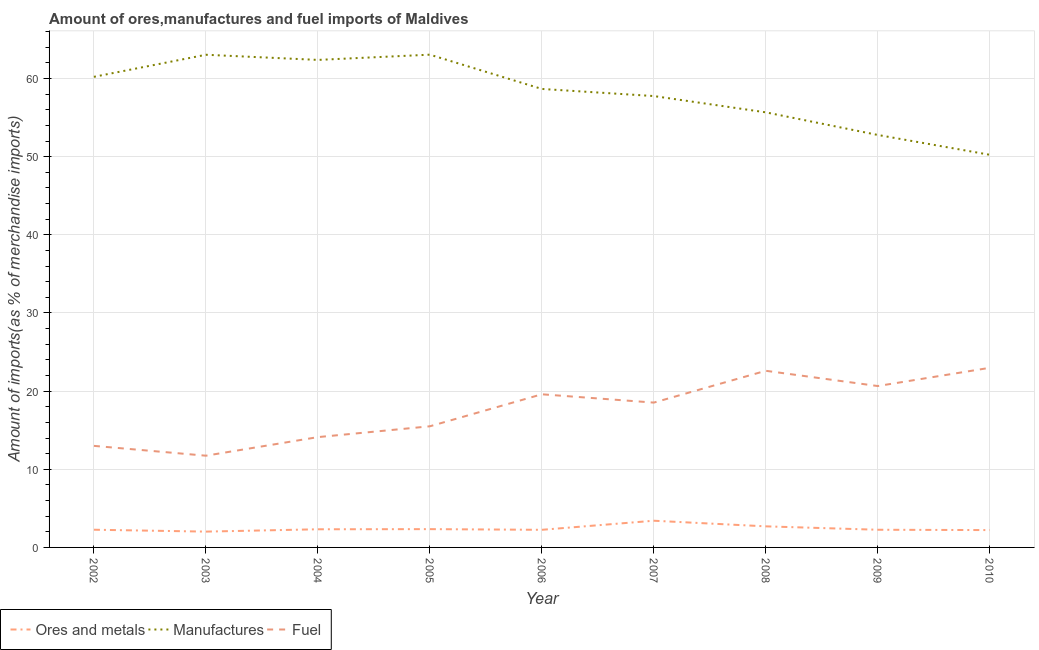Does the line corresponding to percentage of ores and metals imports intersect with the line corresponding to percentage of fuel imports?
Make the answer very short. No. Is the number of lines equal to the number of legend labels?
Offer a terse response. Yes. What is the percentage of fuel imports in 2008?
Offer a terse response. 22.6. Across all years, what is the maximum percentage of manufactures imports?
Make the answer very short. 63.05. Across all years, what is the minimum percentage of fuel imports?
Provide a succinct answer. 11.74. In which year was the percentage of manufactures imports maximum?
Provide a short and direct response. 2005. In which year was the percentage of fuel imports minimum?
Your answer should be very brief. 2003. What is the total percentage of manufactures imports in the graph?
Your response must be concise. 523.8. What is the difference between the percentage of manufactures imports in 2002 and that in 2006?
Offer a very short reply. 1.55. What is the difference between the percentage of fuel imports in 2010 and the percentage of ores and metals imports in 2005?
Make the answer very short. 20.64. What is the average percentage of fuel imports per year?
Offer a terse response. 17.63. In the year 2008, what is the difference between the percentage of fuel imports and percentage of manufactures imports?
Your response must be concise. -33.07. In how many years, is the percentage of fuel imports greater than 36 %?
Offer a terse response. 0. What is the ratio of the percentage of manufactures imports in 2005 to that in 2010?
Ensure brevity in your answer.  1.25. Is the difference between the percentage of ores and metals imports in 2002 and 2010 greater than the difference between the percentage of manufactures imports in 2002 and 2010?
Your response must be concise. No. What is the difference between the highest and the second highest percentage of manufactures imports?
Ensure brevity in your answer.  0.01. What is the difference between the highest and the lowest percentage of fuel imports?
Keep it short and to the point. 11.25. Is the sum of the percentage of ores and metals imports in 2006 and 2009 greater than the maximum percentage of fuel imports across all years?
Keep it short and to the point. No. Is it the case that in every year, the sum of the percentage of ores and metals imports and percentage of manufactures imports is greater than the percentage of fuel imports?
Your response must be concise. Yes. Does the percentage of fuel imports monotonically increase over the years?
Your answer should be compact. No. Is the percentage of manufactures imports strictly greater than the percentage of ores and metals imports over the years?
Provide a short and direct response. Yes. Are the values on the major ticks of Y-axis written in scientific E-notation?
Provide a short and direct response. No. How many legend labels are there?
Ensure brevity in your answer.  3. What is the title of the graph?
Provide a short and direct response. Amount of ores,manufactures and fuel imports of Maldives. What is the label or title of the Y-axis?
Offer a terse response. Amount of imports(as % of merchandise imports). What is the Amount of imports(as % of merchandise imports) of Ores and metals in 2002?
Your answer should be very brief. 2.26. What is the Amount of imports(as % of merchandise imports) of Manufactures in 2002?
Give a very brief answer. 60.22. What is the Amount of imports(as % of merchandise imports) in Fuel in 2002?
Ensure brevity in your answer.  13. What is the Amount of imports(as % of merchandise imports) in Ores and metals in 2003?
Keep it short and to the point. 2.02. What is the Amount of imports(as % of merchandise imports) of Manufactures in 2003?
Ensure brevity in your answer.  63.04. What is the Amount of imports(as % of merchandise imports) in Fuel in 2003?
Offer a terse response. 11.74. What is the Amount of imports(as % of merchandise imports) in Ores and metals in 2004?
Make the answer very short. 2.32. What is the Amount of imports(as % of merchandise imports) in Manufactures in 2004?
Offer a terse response. 62.38. What is the Amount of imports(as % of merchandise imports) in Fuel in 2004?
Give a very brief answer. 14.11. What is the Amount of imports(as % of merchandise imports) in Ores and metals in 2005?
Give a very brief answer. 2.34. What is the Amount of imports(as % of merchandise imports) in Manufactures in 2005?
Your response must be concise. 63.05. What is the Amount of imports(as % of merchandise imports) in Fuel in 2005?
Ensure brevity in your answer.  15.5. What is the Amount of imports(as % of merchandise imports) of Ores and metals in 2006?
Your answer should be very brief. 2.25. What is the Amount of imports(as % of merchandise imports) of Manufactures in 2006?
Offer a terse response. 58.67. What is the Amount of imports(as % of merchandise imports) in Fuel in 2006?
Your response must be concise. 19.6. What is the Amount of imports(as % of merchandise imports) in Ores and metals in 2007?
Your answer should be compact. 3.42. What is the Amount of imports(as % of merchandise imports) in Manufactures in 2007?
Offer a very short reply. 57.75. What is the Amount of imports(as % of merchandise imports) in Fuel in 2007?
Provide a succinct answer. 18.53. What is the Amount of imports(as % of merchandise imports) in Ores and metals in 2008?
Offer a terse response. 2.7. What is the Amount of imports(as % of merchandise imports) of Manufactures in 2008?
Offer a terse response. 55.67. What is the Amount of imports(as % of merchandise imports) of Fuel in 2008?
Give a very brief answer. 22.6. What is the Amount of imports(as % of merchandise imports) in Ores and metals in 2009?
Your response must be concise. 2.26. What is the Amount of imports(as % of merchandise imports) in Manufactures in 2009?
Offer a very short reply. 52.78. What is the Amount of imports(as % of merchandise imports) of Fuel in 2009?
Provide a short and direct response. 20.65. What is the Amount of imports(as % of merchandise imports) in Ores and metals in 2010?
Your answer should be compact. 2.22. What is the Amount of imports(as % of merchandise imports) of Manufactures in 2010?
Your response must be concise. 50.24. What is the Amount of imports(as % of merchandise imports) of Fuel in 2010?
Your answer should be very brief. 22.98. Across all years, what is the maximum Amount of imports(as % of merchandise imports) in Ores and metals?
Keep it short and to the point. 3.42. Across all years, what is the maximum Amount of imports(as % of merchandise imports) of Manufactures?
Offer a terse response. 63.05. Across all years, what is the maximum Amount of imports(as % of merchandise imports) in Fuel?
Ensure brevity in your answer.  22.98. Across all years, what is the minimum Amount of imports(as % of merchandise imports) of Ores and metals?
Provide a succinct answer. 2.02. Across all years, what is the minimum Amount of imports(as % of merchandise imports) of Manufactures?
Your answer should be compact. 50.24. Across all years, what is the minimum Amount of imports(as % of merchandise imports) in Fuel?
Give a very brief answer. 11.74. What is the total Amount of imports(as % of merchandise imports) of Ores and metals in the graph?
Make the answer very short. 21.8. What is the total Amount of imports(as % of merchandise imports) in Manufactures in the graph?
Offer a very short reply. 523.8. What is the total Amount of imports(as % of merchandise imports) of Fuel in the graph?
Provide a succinct answer. 158.71. What is the difference between the Amount of imports(as % of merchandise imports) of Ores and metals in 2002 and that in 2003?
Make the answer very short. 0.24. What is the difference between the Amount of imports(as % of merchandise imports) of Manufactures in 2002 and that in 2003?
Make the answer very short. -2.82. What is the difference between the Amount of imports(as % of merchandise imports) of Fuel in 2002 and that in 2003?
Give a very brief answer. 1.26. What is the difference between the Amount of imports(as % of merchandise imports) of Ores and metals in 2002 and that in 2004?
Your response must be concise. -0.06. What is the difference between the Amount of imports(as % of merchandise imports) of Manufactures in 2002 and that in 2004?
Offer a terse response. -2.16. What is the difference between the Amount of imports(as % of merchandise imports) in Fuel in 2002 and that in 2004?
Offer a very short reply. -1.12. What is the difference between the Amount of imports(as % of merchandise imports) of Ores and metals in 2002 and that in 2005?
Your answer should be compact. -0.08. What is the difference between the Amount of imports(as % of merchandise imports) in Manufactures in 2002 and that in 2005?
Your answer should be compact. -2.83. What is the difference between the Amount of imports(as % of merchandise imports) in Fuel in 2002 and that in 2005?
Your answer should be compact. -2.5. What is the difference between the Amount of imports(as % of merchandise imports) in Ores and metals in 2002 and that in 2006?
Offer a very short reply. 0.01. What is the difference between the Amount of imports(as % of merchandise imports) of Manufactures in 2002 and that in 2006?
Ensure brevity in your answer.  1.55. What is the difference between the Amount of imports(as % of merchandise imports) in Fuel in 2002 and that in 2006?
Offer a terse response. -6.6. What is the difference between the Amount of imports(as % of merchandise imports) in Ores and metals in 2002 and that in 2007?
Ensure brevity in your answer.  -1.15. What is the difference between the Amount of imports(as % of merchandise imports) in Manufactures in 2002 and that in 2007?
Give a very brief answer. 2.46. What is the difference between the Amount of imports(as % of merchandise imports) in Fuel in 2002 and that in 2007?
Give a very brief answer. -5.54. What is the difference between the Amount of imports(as % of merchandise imports) of Ores and metals in 2002 and that in 2008?
Make the answer very short. -0.43. What is the difference between the Amount of imports(as % of merchandise imports) of Manufactures in 2002 and that in 2008?
Offer a very short reply. 4.54. What is the difference between the Amount of imports(as % of merchandise imports) of Fuel in 2002 and that in 2008?
Your response must be concise. -9.61. What is the difference between the Amount of imports(as % of merchandise imports) of Ores and metals in 2002 and that in 2009?
Provide a short and direct response. 0. What is the difference between the Amount of imports(as % of merchandise imports) of Manufactures in 2002 and that in 2009?
Give a very brief answer. 7.44. What is the difference between the Amount of imports(as % of merchandise imports) of Fuel in 2002 and that in 2009?
Give a very brief answer. -7.66. What is the difference between the Amount of imports(as % of merchandise imports) of Ores and metals in 2002 and that in 2010?
Give a very brief answer. 0.05. What is the difference between the Amount of imports(as % of merchandise imports) in Manufactures in 2002 and that in 2010?
Keep it short and to the point. 9.97. What is the difference between the Amount of imports(as % of merchandise imports) of Fuel in 2002 and that in 2010?
Offer a terse response. -9.99. What is the difference between the Amount of imports(as % of merchandise imports) in Ores and metals in 2003 and that in 2004?
Offer a very short reply. -0.3. What is the difference between the Amount of imports(as % of merchandise imports) of Manufactures in 2003 and that in 2004?
Your answer should be compact. 0.66. What is the difference between the Amount of imports(as % of merchandise imports) in Fuel in 2003 and that in 2004?
Offer a terse response. -2.38. What is the difference between the Amount of imports(as % of merchandise imports) in Ores and metals in 2003 and that in 2005?
Provide a succinct answer. -0.32. What is the difference between the Amount of imports(as % of merchandise imports) of Manufactures in 2003 and that in 2005?
Your response must be concise. -0.01. What is the difference between the Amount of imports(as % of merchandise imports) in Fuel in 2003 and that in 2005?
Give a very brief answer. -3.76. What is the difference between the Amount of imports(as % of merchandise imports) in Ores and metals in 2003 and that in 2006?
Provide a short and direct response. -0.23. What is the difference between the Amount of imports(as % of merchandise imports) of Manufactures in 2003 and that in 2006?
Your response must be concise. 4.37. What is the difference between the Amount of imports(as % of merchandise imports) in Fuel in 2003 and that in 2006?
Your answer should be compact. -7.86. What is the difference between the Amount of imports(as % of merchandise imports) in Ores and metals in 2003 and that in 2007?
Your response must be concise. -1.39. What is the difference between the Amount of imports(as % of merchandise imports) of Manufactures in 2003 and that in 2007?
Give a very brief answer. 5.28. What is the difference between the Amount of imports(as % of merchandise imports) of Fuel in 2003 and that in 2007?
Provide a short and direct response. -6.79. What is the difference between the Amount of imports(as % of merchandise imports) in Ores and metals in 2003 and that in 2008?
Your answer should be compact. -0.67. What is the difference between the Amount of imports(as % of merchandise imports) of Manufactures in 2003 and that in 2008?
Provide a short and direct response. 7.37. What is the difference between the Amount of imports(as % of merchandise imports) of Fuel in 2003 and that in 2008?
Your answer should be very brief. -10.87. What is the difference between the Amount of imports(as % of merchandise imports) of Ores and metals in 2003 and that in 2009?
Provide a short and direct response. -0.24. What is the difference between the Amount of imports(as % of merchandise imports) in Manufactures in 2003 and that in 2009?
Provide a succinct answer. 10.26. What is the difference between the Amount of imports(as % of merchandise imports) of Fuel in 2003 and that in 2009?
Offer a very short reply. -8.91. What is the difference between the Amount of imports(as % of merchandise imports) in Ores and metals in 2003 and that in 2010?
Your response must be concise. -0.2. What is the difference between the Amount of imports(as % of merchandise imports) in Manufactures in 2003 and that in 2010?
Give a very brief answer. 12.8. What is the difference between the Amount of imports(as % of merchandise imports) in Fuel in 2003 and that in 2010?
Offer a terse response. -11.25. What is the difference between the Amount of imports(as % of merchandise imports) in Ores and metals in 2004 and that in 2005?
Offer a very short reply. -0.02. What is the difference between the Amount of imports(as % of merchandise imports) in Manufactures in 2004 and that in 2005?
Give a very brief answer. -0.67. What is the difference between the Amount of imports(as % of merchandise imports) of Fuel in 2004 and that in 2005?
Your response must be concise. -1.39. What is the difference between the Amount of imports(as % of merchandise imports) of Ores and metals in 2004 and that in 2006?
Your response must be concise. 0.07. What is the difference between the Amount of imports(as % of merchandise imports) in Manufactures in 2004 and that in 2006?
Provide a succinct answer. 3.71. What is the difference between the Amount of imports(as % of merchandise imports) of Fuel in 2004 and that in 2006?
Provide a succinct answer. -5.48. What is the difference between the Amount of imports(as % of merchandise imports) in Ores and metals in 2004 and that in 2007?
Your answer should be compact. -1.09. What is the difference between the Amount of imports(as % of merchandise imports) of Manufactures in 2004 and that in 2007?
Provide a succinct answer. 4.63. What is the difference between the Amount of imports(as % of merchandise imports) in Fuel in 2004 and that in 2007?
Keep it short and to the point. -4.42. What is the difference between the Amount of imports(as % of merchandise imports) of Ores and metals in 2004 and that in 2008?
Offer a terse response. -0.37. What is the difference between the Amount of imports(as % of merchandise imports) of Manufactures in 2004 and that in 2008?
Your answer should be compact. 6.71. What is the difference between the Amount of imports(as % of merchandise imports) in Fuel in 2004 and that in 2008?
Provide a short and direct response. -8.49. What is the difference between the Amount of imports(as % of merchandise imports) in Ores and metals in 2004 and that in 2009?
Offer a very short reply. 0.06. What is the difference between the Amount of imports(as % of merchandise imports) of Manufactures in 2004 and that in 2009?
Provide a succinct answer. 9.6. What is the difference between the Amount of imports(as % of merchandise imports) of Fuel in 2004 and that in 2009?
Your answer should be very brief. -6.54. What is the difference between the Amount of imports(as % of merchandise imports) in Ores and metals in 2004 and that in 2010?
Your answer should be compact. 0.1. What is the difference between the Amount of imports(as % of merchandise imports) in Manufactures in 2004 and that in 2010?
Your response must be concise. 12.14. What is the difference between the Amount of imports(as % of merchandise imports) in Fuel in 2004 and that in 2010?
Your answer should be compact. -8.87. What is the difference between the Amount of imports(as % of merchandise imports) in Ores and metals in 2005 and that in 2006?
Offer a very short reply. 0.09. What is the difference between the Amount of imports(as % of merchandise imports) of Manufactures in 2005 and that in 2006?
Ensure brevity in your answer.  4.38. What is the difference between the Amount of imports(as % of merchandise imports) in Fuel in 2005 and that in 2006?
Make the answer very short. -4.1. What is the difference between the Amount of imports(as % of merchandise imports) in Ores and metals in 2005 and that in 2007?
Give a very brief answer. -1.07. What is the difference between the Amount of imports(as % of merchandise imports) of Manufactures in 2005 and that in 2007?
Ensure brevity in your answer.  5.3. What is the difference between the Amount of imports(as % of merchandise imports) in Fuel in 2005 and that in 2007?
Keep it short and to the point. -3.03. What is the difference between the Amount of imports(as % of merchandise imports) in Ores and metals in 2005 and that in 2008?
Your answer should be very brief. -0.36. What is the difference between the Amount of imports(as % of merchandise imports) in Manufactures in 2005 and that in 2008?
Keep it short and to the point. 7.38. What is the difference between the Amount of imports(as % of merchandise imports) in Fuel in 2005 and that in 2008?
Keep it short and to the point. -7.1. What is the difference between the Amount of imports(as % of merchandise imports) of Ores and metals in 2005 and that in 2009?
Give a very brief answer. 0.08. What is the difference between the Amount of imports(as % of merchandise imports) in Manufactures in 2005 and that in 2009?
Your answer should be compact. 10.27. What is the difference between the Amount of imports(as % of merchandise imports) of Fuel in 2005 and that in 2009?
Your answer should be very brief. -5.15. What is the difference between the Amount of imports(as % of merchandise imports) of Ores and metals in 2005 and that in 2010?
Give a very brief answer. 0.12. What is the difference between the Amount of imports(as % of merchandise imports) in Manufactures in 2005 and that in 2010?
Your answer should be compact. 12.81. What is the difference between the Amount of imports(as % of merchandise imports) of Fuel in 2005 and that in 2010?
Provide a short and direct response. -7.48. What is the difference between the Amount of imports(as % of merchandise imports) of Ores and metals in 2006 and that in 2007?
Make the answer very short. -1.16. What is the difference between the Amount of imports(as % of merchandise imports) of Manufactures in 2006 and that in 2007?
Provide a short and direct response. 0.91. What is the difference between the Amount of imports(as % of merchandise imports) in Fuel in 2006 and that in 2007?
Make the answer very short. 1.06. What is the difference between the Amount of imports(as % of merchandise imports) in Ores and metals in 2006 and that in 2008?
Give a very brief answer. -0.44. What is the difference between the Amount of imports(as % of merchandise imports) of Manufactures in 2006 and that in 2008?
Provide a succinct answer. 2.99. What is the difference between the Amount of imports(as % of merchandise imports) of Fuel in 2006 and that in 2008?
Your response must be concise. -3.01. What is the difference between the Amount of imports(as % of merchandise imports) in Ores and metals in 2006 and that in 2009?
Offer a very short reply. -0.01. What is the difference between the Amount of imports(as % of merchandise imports) in Manufactures in 2006 and that in 2009?
Give a very brief answer. 5.89. What is the difference between the Amount of imports(as % of merchandise imports) of Fuel in 2006 and that in 2009?
Provide a succinct answer. -1.06. What is the difference between the Amount of imports(as % of merchandise imports) in Ores and metals in 2006 and that in 2010?
Offer a terse response. 0.04. What is the difference between the Amount of imports(as % of merchandise imports) of Manufactures in 2006 and that in 2010?
Offer a very short reply. 8.42. What is the difference between the Amount of imports(as % of merchandise imports) of Fuel in 2006 and that in 2010?
Give a very brief answer. -3.39. What is the difference between the Amount of imports(as % of merchandise imports) of Ores and metals in 2007 and that in 2008?
Ensure brevity in your answer.  0.72. What is the difference between the Amount of imports(as % of merchandise imports) of Manufactures in 2007 and that in 2008?
Ensure brevity in your answer.  2.08. What is the difference between the Amount of imports(as % of merchandise imports) in Fuel in 2007 and that in 2008?
Your answer should be very brief. -4.07. What is the difference between the Amount of imports(as % of merchandise imports) of Ores and metals in 2007 and that in 2009?
Your answer should be very brief. 1.15. What is the difference between the Amount of imports(as % of merchandise imports) in Manufactures in 2007 and that in 2009?
Provide a short and direct response. 4.98. What is the difference between the Amount of imports(as % of merchandise imports) of Fuel in 2007 and that in 2009?
Your response must be concise. -2.12. What is the difference between the Amount of imports(as % of merchandise imports) in Ores and metals in 2007 and that in 2010?
Keep it short and to the point. 1.2. What is the difference between the Amount of imports(as % of merchandise imports) in Manufactures in 2007 and that in 2010?
Make the answer very short. 7.51. What is the difference between the Amount of imports(as % of merchandise imports) in Fuel in 2007 and that in 2010?
Offer a very short reply. -4.45. What is the difference between the Amount of imports(as % of merchandise imports) in Ores and metals in 2008 and that in 2009?
Your answer should be compact. 0.43. What is the difference between the Amount of imports(as % of merchandise imports) of Manufactures in 2008 and that in 2009?
Your answer should be compact. 2.89. What is the difference between the Amount of imports(as % of merchandise imports) in Fuel in 2008 and that in 2009?
Provide a short and direct response. 1.95. What is the difference between the Amount of imports(as % of merchandise imports) in Ores and metals in 2008 and that in 2010?
Your response must be concise. 0.48. What is the difference between the Amount of imports(as % of merchandise imports) in Manufactures in 2008 and that in 2010?
Give a very brief answer. 5.43. What is the difference between the Amount of imports(as % of merchandise imports) of Fuel in 2008 and that in 2010?
Your answer should be compact. -0.38. What is the difference between the Amount of imports(as % of merchandise imports) in Ores and metals in 2009 and that in 2010?
Your answer should be compact. 0.04. What is the difference between the Amount of imports(as % of merchandise imports) of Manufactures in 2009 and that in 2010?
Your answer should be very brief. 2.54. What is the difference between the Amount of imports(as % of merchandise imports) in Fuel in 2009 and that in 2010?
Your answer should be very brief. -2.33. What is the difference between the Amount of imports(as % of merchandise imports) of Ores and metals in 2002 and the Amount of imports(as % of merchandise imports) of Manufactures in 2003?
Ensure brevity in your answer.  -60.77. What is the difference between the Amount of imports(as % of merchandise imports) in Ores and metals in 2002 and the Amount of imports(as % of merchandise imports) in Fuel in 2003?
Keep it short and to the point. -9.47. What is the difference between the Amount of imports(as % of merchandise imports) in Manufactures in 2002 and the Amount of imports(as % of merchandise imports) in Fuel in 2003?
Make the answer very short. 48.48. What is the difference between the Amount of imports(as % of merchandise imports) in Ores and metals in 2002 and the Amount of imports(as % of merchandise imports) in Manufactures in 2004?
Keep it short and to the point. -60.12. What is the difference between the Amount of imports(as % of merchandise imports) in Ores and metals in 2002 and the Amount of imports(as % of merchandise imports) in Fuel in 2004?
Keep it short and to the point. -11.85. What is the difference between the Amount of imports(as % of merchandise imports) in Manufactures in 2002 and the Amount of imports(as % of merchandise imports) in Fuel in 2004?
Keep it short and to the point. 46.1. What is the difference between the Amount of imports(as % of merchandise imports) of Ores and metals in 2002 and the Amount of imports(as % of merchandise imports) of Manufactures in 2005?
Provide a short and direct response. -60.79. What is the difference between the Amount of imports(as % of merchandise imports) of Ores and metals in 2002 and the Amount of imports(as % of merchandise imports) of Fuel in 2005?
Make the answer very short. -13.24. What is the difference between the Amount of imports(as % of merchandise imports) of Manufactures in 2002 and the Amount of imports(as % of merchandise imports) of Fuel in 2005?
Your answer should be compact. 44.72. What is the difference between the Amount of imports(as % of merchandise imports) of Ores and metals in 2002 and the Amount of imports(as % of merchandise imports) of Manufactures in 2006?
Offer a very short reply. -56.4. What is the difference between the Amount of imports(as % of merchandise imports) of Ores and metals in 2002 and the Amount of imports(as % of merchandise imports) of Fuel in 2006?
Your response must be concise. -17.33. What is the difference between the Amount of imports(as % of merchandise imports) in Manufactures in 2002 and the Amount of imports(as % of merchandise imports) in Fuel in 2006?
Offer a very short reply. 40.62. What is the difference between the Amount of imports(as % of merchandise imports) in Ores and metals in 2002 and the Amount of imports(as % of merchandise imports) in Manufactures in 2007?
Keep it short and to the point. -55.49. What is the difference between the Amount of imports(as % of merchandise imports) in Ores and metals in 2002 and the Amount of imports(as % of merchandise imports) in Fuel in 2007?
Your response must be concise. -16.27. What is the difference between the Amount of imports(as % of merchandise imports) in Manufactures in 2002 and the Amount of imports(as % of merchandise imports) in Fuel in 2007?
Provide a short and direct response. 41.68. What is the difference between the Amount of imports(as % of merchandise imports) in Ores and metals in 2002 and the Amount of imports(as % of merchandise imports) in Manufactures in 2008?
Your answer should be very brief. -53.41. What is the difference between the Amount of imports(as % of merchandise imports) of Ores and metals in 2002 and the Amount of imports(as % of merchandise imports) of Fuel in 2008?
Your answer should be compact. -20.34. What is the difference between the Amount of imports(as % of merchandise imports) in Manufactures in 2002 and the Amount of imports(as % of merchandise imports) in Fuel in 2008?
Your response must be concise. 37.61. What is the difference between the Amount of imports(as % of merchandise imports) of Ores and metals in 2002 and the Amount of imports(as % of merchandise imports) of Manufactures in 2009?
Your answer should be compact. -50.51. What is the difference between the Amount of imports(as % of merchandise imports) of Ores and metals in 2002 and the Amount of imports(as % of merchandise imports) of Fuel in 2009?
Your answer should be very brief. -18.39. What is the difference between the Amount of imports(as % of merchandise imports) of Manufactures in 2002 and the Amount of imports(as % of merchandise imports) of Fuel in 2009?
Offer a terse response. 39.57. What is the difference between the Amount of imports(as % of merchandise imports) of Ores and metals in 2002 and the Amount of imports(as % of merchandise imports) of Manufactures in 2010?
Offer a very short reply. -47.98. What is the difference between the Amount of imports(as % of merchandise imports) in Ores and metals in 2002 and the Amount of imports(as % of merchandise imports) in Fuel in 2010?
Your answer should be compact. -20.72. What is the difference between the Amount of imports(as % of merchandise imports) of Manufactures in 2002 and the Amount of imports(as % of merchandise imports) of Fuel in 2010?
Offer a very short reply. 37.23. What is the difference between the Amount of imports(as % of merchandise imports) of Ores and metals in 2003 and the Amount of imports(as % of merchandise imports) of Manufactures in 2004?
Your answer should be compact. -60.36. What is the difference between the Amount of imports(as % of merchandise imports) of Ores and metals in 2003 and the Amount of imports(as % of merchandise imports) of Fuel in 2004?
Keep it short and to the point. -12.09. What is the difference between the Amount of imports(as % of merchandise imports) in Manufactures in 2003 and the Amount of imports(as % of merchandise imports) in Fuel in 2004?
Offer a very short reply. 48.93. What is the difference between the Amount of imports(as % of merchandise imports) of Ores and metals in 2003 and the Amount of imports(as % of merchandise imports) of Manufactures in 2005?
Offer a terse response. -61.03. What is the difference between the Amount of imports(as % of merchandise imports) of Ores and metals in 2003 and the Amount of imports(as % of merchandise imports) of Fuel in 2005?
Provide a succinct answer. -13.48. What is the difference between the Amount of imports(as % of merchandise imports) in Manufactures in 2003 and the Amount of imports(as % of merchandise imports) in Fuel in 2005?
Ensure brevity in your answer.  47.54. What is the difference between the Amount of imports(as % of merchandise imports) in Ores and metals in 2003 and the Amount of imports(as % of merchandise imports) in Manufactures in 2006?
Give a very brief answer. -56.64. What is the difference between the Amount of imports(as % of merchandise imports) in Ores and metals in 2003 and the Amount of imports(as % of merchandise imports) in Fuel in 2006?
Your answer should be compact. -17.57. What is the difference between the Amount of imports(as % of merchandise imports) in Manufactures in 2003 and the Amount of imports(as % of merchandise imports) in Fuel in 2006?
Give a very brief answer. 43.44. What is the difference between the Amount of imports(as % of merchandise imports) of Ores and metals in 2003 and the Amount of imports(as % of merchandise imports) of Manufactures in 2007?
Provide a short and direct response. -55.73. What is the difference between the Amount of imports(as % of merchandise imports) of Ores and metals in 2003 and the Amount of imports(as % of merchandise imports) of Fuel in 2007?
Your answer should be compact. -16.51. What is the difference between the Amount of imports(as % of merchandise imports) of Manufactures in 2003 and the Amount of imports(as % of merchandise imports) of Fuel in 2007?
Your answer should be compact. 44.51. What is the difference between the Amount of imports(as % of merchandise imports) of Ores and metals in 2003 and the Amount of imports(as % of merchandise imports) of Manufactures in 2008?
Your answer should be compact. -53.65. What is the difference between the Amount of imports(as % of merchandise imports) of Ores and metals in 2003 and the Amount of imports(as % of merchandise imports) of Fuel in 2008?
Make the answer very short. -20.58. What is the difference between the Amount of imports(as % of merchandise imports) of Manufactures in 2003 and the Amount of imports(as % of merchandise imports) of Fuel in 2008?
Offer a very short reply. 40.44. What is the difference between the Amount of imports(as % of merchandise imports) in Ores and metals in 2003 and the Amount of imports(as % of merchandise imports) in Manufactures in 2009?
Ensure brevity in your answer.  -50.76. What is the difference between the Amount of imports(as % of merchandise imports) in Ores and metals in 2003 and the Amount of imports(as % of merchandise imports) in Fuel in 2009?
Your answer should be compact. -18.63. What is the difference between the Amount of imports(as % of merchandise imports) in Manufactures in 2003 and the Amount of imports(as % of merchandise imports) in Fuel in 2009?
Ensure brevity in your answer.  42.39. What is the difference between the Amount of imports(as % of merchandise imports) in Ores and metals in 2003 and the Amount of imports(as % of merchandise imports) in Manufactures in 2010?
Your answer should be compact. -48.22. What is the difference between the Amount of imports(as % of merchandise imports) of Ores and metals in 2003 and the Amount of imports(as % of merchandise imports) of Fuel in 2010?
Keep it short and to the point. -20.96. What is the difference between the Amount of imports(as % of merchandise imports) in Manufactures in 2003 and the Amount of imports(as % of merchandise imports) in Fuel in 2010?
Keep it short and to the point. 40.06. What is the difference between the Amount of imports(as % of merchandise imports) in Ores and metals in 2004 and the Amount of imports(as % of merchandise imports) in Manufactures in 2005?
Give a very brief answer. -60.73. What is the difference between the Amount of imports(as % of merchandise imports) in Ores and metals in 2004 and the Amount of imports(as % of merchandise imports) in Fuel in 2005?
Keep it short and to the point. -13.18. What is the difference between the Amount of imports(as % of merchandise imports) of Manufactures in 2004 and the Amount of imports(as % of merchandise imports) of Fuel in 2005?
Offer a terse response. 46.88. What is the difference between the Amount of imports(as % of merchandise imports) in Ores and metals in 2004 and the Amount of imports(as % of merchandise imports) in Manufactures in 2006?
Give a very brief answer. -56.34. What is the difference between the Amount of imports(as % of merchandise imports) of Ores and metals in 2004 and the Amount of imports(as % of merchandise imports) of Fuel in 2006?
Provide a succinct answer. -17.27. What is the difference between the Amount of imports(as % of merchandise imports) in Manufactures in 2004 and the Amount of imports(as % of merchandise imports) in Fuel in 2006?
Provide a short and direct response. 42.78. What is the difference between the Amount of imports(as % of merchandise imports) in Ores and metals in 2004 and the Amount of imports(as % of merchandise imports) in Manufactures in 2007?
Give a very brief answer. -55.43. What is the difference between the Amount of imports(as % of merchandise imports) in Ores and metals in 2004 and the Amount of imports(as % of merchandise imports) in Fuel in 2007?
Offer a terse response. -16.21. What is the difference between the Amount of imports(as % of merchandise imports) in Manufactures in 2004 and the Amount of imports(as % of merchandise imports) in Fuel in 2007?
Provide a succinct answer. 43.85. What is the difference between the Amount of imports(as % of merchandise imports) in Ores and metals in 2004 and the Amount of imports(as % of merchandise imports) in Manufactures in 2008?
Offer a very short reply. -53.35. What is the difference between the Amount of imports(as % of merchandise imports) of Ores and metals in 2004 and the Amount of imports(as % of merchandise imports) of Fuel in 2008?
Make the answer very short. -20.28. What is the difference between the Amount of imports(as % of merchandise imports) of Manufactures in 2004 and the Amount of imports(as % of merchandise imports) of Fuel in 2008?
Your response must be concise. 39.78. What is the difference between the Amount of imports(as % of merchandise imports) in Ores and metals in 2004 and the Amount of imports(as % of merchandise imports) in Manufactures in 2009?
Your answer should be very brief. -50.46. What is the difference between the Amount of imports(as % of merchandise imports) in Ores and metals in 2004 and the Amount of imports(as % of merchandise imports) in Fuel in 2009?
Give a very brief answer. -18.33. What is the difference between the Amount of imports(as % of merchandise imports) of Manufactures in 2004 and the Amount of imports(as % of merchandise imports) of Fuel in 2009?
Offer a terse response. 41.73. What is the difference between the Amount of imports(as % of merchandise imports) of Ores and metals in 2004 and the Amount of imports(as % of merchandise imports) of Manufactures in 2010?
Make the answer very short. -47.92. What is the difference between the Amount of imports(as % of merchandise imports) of Ores and metals in 2004 and the Amount of imports(as % of merchandise imports) of Fuel in 2010?
Offer a very short reply. -20.66. What is the difference between the Amount of imports(as % of merchandise imports) of Manufactures in 2004 and the Amount of imports(as % of merchandise imports) of Fuel in 2010?
Make the answer very short. 39.4. What is the difference between the Amount of imports(as % of merchandise imports) of Ores and metals in 2005 and the Amount of imports(as % of merchandise imports) of Manufactures in 2006?
Ensure brevity in your answer.  -56.32. What is the difference between the Amount of imports(as % of merchandise imports) of Ores and metals in 2005 and the Amount of imports(as % of merchandise imports) of Fuel in 2006?
Make the answer very short. -17.25. What is the difference between the Amount of imports(as % of merchandise imports) in Manufactures in 2005 and the Amount of imports(as % of merchandise imports) in Fuel in 2006?
Your response must be concise. 43.46. What is the difference between the Amount of imports(as % of merchandise imports) in Ores and metals in 2005 and the Amount of imports(as % of merchandise imports) in Manufactures in 2007?
Give a very brief answer. -55.41. What is the difference between the Amount of imports(as % of merchandise imports) in Ores and metals in 2005 and the Amount of imports(as % of merchandise imports) in Fuel in 2007?
Offer a very short reply. -16.19. What is the difference between the Amount of imports(as % of merchandise imports) of Manufactures in 2005 and the Amount of imports(as % of merchandise imports) of Fuel in 2007?
Your response must be concise. 44.52. What is the difference between the Amount of imports(as % of merchandise imports) in Ores and metals in 2005 and the Amount of imports(as % of merchandise imports) in Manufactures in 2008?
Give a very brief answer. -53.33. What is the difference between the Amount of imports(as % of merchandise imports) in Ores and metals in 2005 and the Amount of imports(as % of merchandise imports) in Fuel in 2008?
Ensure brevity in your answer.  -20.26. What is the difference between the Amount of imports(as % of merchandise imports) in Manufactures in 2005 and the Amount of imports(as % of merchandise imports) in Fuel in 2008?
Provide a short and direct response. 40.45. What is the difference between the Amount of imports(as % of merchandise imports) in Ores and metals in 2005 and the Amount of imports(as % of merchandise imports) in Manufactures in 2009?
Keep it short and to the point. -50.44. What is the difference between the Amount of imports(as % of merchandise imports) in Ores and metals in 2005 and the Amount of imports(as % of merchandise imports) in Fuel in 2009?
Your answer should be very brief. -18.31. What is the difference between the Amount of imports(as % of merchandise imports) in Manufactures in 2005 and the Amount of imports(as % of merchandise imports) in Fuel in 2009?
Your answer should be very brief. 42.4. What is the difference between the Amount of imports(as % of merchandise imports) in Ores and metals in 2005 and the Amount of imports(as % of merchandise imports) in Manufactures in 2010?
Ensure brevity in your answer.  -47.9. What is the difference between the Amount of imports(as % of merchandise imports) of Ores and metals in 2005 and the Amount of imports(as % of merchandise imports) of Fuel in 2010?
Provide a short and direct response. -20.64. What is the difference between the Amount of imports(as % of merchandise imports) in Manufactures in 2005 and the Amount of imports(as % of merchandise imports) in Fuel in 2010?
Your answer should be very brief. 40.07. What is the difference between the Amount of imports(as % of merchandise imports) in Ores and metals in 2006 and the Amount of imports(as % of merchandise imports) in Manufactures in 2007?
Offer a very short reply. -55.5. What is the difference between the Amount of imports(as % of merchandise imports) of Ores and metals in 2006 and the Amount of imports(as % of merchandise imports) of Fuel in 2007?
Make the answer very short. -16.28. What is the difference between the Amount of imports(as % of merchandise imports) of Manufactures in 2006 and the Amount of imports(as % of merchandise imports) of Fuel in 2007?
Provide a short and direct response. 40.13. What is the difference between the Amount of imports(as % of merchandise imports) in Ores and metals in 2006 and the Amount of imports(as % of merchandise imports) in Manufactures in 2008?
Your answer should be very brief. -53.42. What is the difference between the Amount of imports(as % of merchandise imports) in Ores and metals in 2006 and the Amount of imports(as % of merchandise imports) in Fuel in 2008?
Ensure brevity in your answer.  -20.35. What is the difference between the Amount of imports(as % of merchandise imports) in Manufactures in 2006 and the Amount of imports(as % of merchandise imports) in Fuel in 2008?
Offer a terse response. 36.06. What is the difference between the Amount of imports(as % of merchandise imports) in Ores and metals in 2006 and the Amount of imports(as % of merchandise imports) in Manufactures in 2009?
Make the answer very short. -50.52. What is the difference between the Amount of imports(as % of merchandise imports) of Ores and metals in 2006 and the Amount of imports(as % of merchandise imports) of Fuel in 2009?
Your answer should be compact. -18.4. What is the difference between the Amount of imports(as % of merchandise imports) of Manufactures in 2006 and the Amount of imports(as % of merchandise imports) of Fuel in 2009?
Ensure brevity in your answer.  38.02. What is the difference between the Amount of imports(as % of merchandise imports) in Ores and metals in 2006 and the Amount of imports(as % of merchandise imports) in Manufactures in 2010?
Provide a short and direct response. -47.99. What is the difference between the Amount of imports(as % of merchandise imports) of Ores and metals in 2006 and the Amount of imports(as % of merchandise imports) of Fuel in 2010?
Make the answer very short. -20.73. What is the difference between the Amount of imports(as % of merchandise imports) of Manufactures in 2006 and the Amount of imports(as % of merchandise imports) of Fuel in 2010?
Give a very brief answer. 35.68. What is the difference between the Amount of imports(as % of merchandise imports) of Ores and metals in 2007 and the Amount of imports(as % of merchandise imports) of Manufactures in 2008?
Offer a terse response. -52.26. What is the difference between the Amount of imports(as % of merchandise imports) of Ores and metals in 2007 and the Amount of imports(as % of merchandise imports) of Fuel in 2008?
Give a very brief answer. -19.19. What is the difference between the Amount of imports(as % of merchandise imports) in Manufactures in 2007 and the Amount of imports(as % of merchandise imports) in Fuel in 2008?
Make the answer very short. 35.15. What is the difference between the Amount of imports(as % of merchandise imports) in Ores and metals in 2007 and the Amount of imports(as % of merchandise imports) in Manufactures in 2009?
Provide a succinct answer. -49.36. What is the difference between the Amount of imports(as % of merchandise imports) of Ores and metals in 2007 and the Amount of imports(as % of merchandise imports) of Fuel in 2009?
Provide a succinct answer. -17.23. What is the difference between the Amount of imports(as % of merchandise imports) of Manufactures in 2007 and the Amount of imports(as % of merchandise imports) of Fuel in 2009?
Give a very brief answer. 37.1. What is the difference between the Amount of imports(as % of merchandise imports) of Ores and metals in 2007 and the Amount of imports(as % of merchandise imports) of Manufactures in 2010?
Offer a very short reply. -46.83. What is the difference between the Amount of imports(as % of merchandise imports) of Ores and metals in 2007 and the Amount of imports(as % of merchandise imports) of Fuel in 2010?
Provide a short and direct response. -19.57. What is the difference between the Amount of imports(as % of merchandise imports) of Manufactures in 2007 and the Amount of imports(as % of merchandise imports) of Fuel in 2010?
Your answer should be compact. 34.77. What is the difference between the Amount of imports(as % of merchandise imports) in Ores and metals in 2008 and the Amount of imports(as % of merchandise imports) in Manufactures in 2009?
Ensure brevity in your answer.  -50.08. What is the difference between the Amount of imports(as % of merchandise imports) in Ores and metals in 2008 and the Amount of imports(as % of merchandise imports) in Fuel in 2009?
Make the answer very short. -17.95. What is the difference between the Amount of imports(as % of merchandise imports) in Manufactures in 2008 and the Amount of imports(as % of merchandise imports) in Fuel in 2009?
Provide a succinct answer. 35.02. What is the difference between the Amount of imports(as % of merchandise imports) of Ores and metals in 2008 and the Amount of imports(as % of merchandise imports) of Manufactures in 2010?
Offer a terse response. -47.55. What is the difference between the Amount of imports(as % of merchandise imports) in Ores and metals in 2008 and the Amount of imports(as % of merchandise imports) in Fuel in 2010?
Provide a short and direct response. -20.29. What is the difference between the Amount of imports(as % of merchandise imports) of Manufactures in 2008 and the Amount of imports(as % of merchandise imports) of Fuel in 2010?
Offer a terse response. 32.69. What is the difference between the Amount of imports(as % of merchandise imports) of Ores and metals in 2009 and the Amount of imports(as % of merchandise imports) of Manufactures in 2010?
Your answer should be very brief. -47.98. What is the difference between the Amount of imports(as % of merchandise imports) in Ores and metals in 2009 and the Amount of imports(as % of merchandise imports) in Fuel in 2010?
Provide a short and direct response. -20.72. What is the difference between the Amount of imports(as % of merchandise imports) of Manufactures in 2009 and the Amount of imports(as % of merchandise imports) of Fuel in 2010?
Provide a short and direct response. 29.8. What is the average Amount of imports(as % of merchandise imports) of Ores and metals per year?
Provide a succinct answer. 2.42. What is the average Amount of imports(as % of merchandise imports) of Manufactures per year?
Provide a short and direct response. 58.2. What is the average Amount of imports(as % of merchandise imports) in Fuel per year?
Your answer should be compact. 17.63. In the year 2002, what is the difference between the Amount of imports(as % of merchandise imports) of Ores and metals and Amount of imports(as % of merchandise imports) of Manufactures?
Ensure brevity in your answer.  -57.95. In the year 2002, what is the difference between the Amount of imports(as % of merchandise imports) in Ores and metals and Amount of imports(as % of merchandise imports) in Fuel?
Your response must be concise. -10.73. In the year 2002, what is the difference between the Amount of imports(as % of merchandise imports) of Manufactures and Amount of imports(as % of merchandise imports) of Fuel?
Provide a short and direct response. 47.22. In the year 2003, what is the difference between the Amount of imports(as % of merchandise imports) of Ores and metals and Amount of imports(as % of merchandise imports) of Manufactures?
Offer a terse response. -61.02. In the year 2003, what is the difference between the Amount of imports(as % of merchandise imports) in Ores and metals and Amount of imports(as % of merchandise imports) in Fuel?
Offer a terse response. -9.71. In the year 2003, what is the difference between the Amount of imports(as % of merchandise imports) of Manufactures and Amount of imports(as % of merchandise imports) of Fuel?
Ensure brevity in your answer.  51.3. In the year 2004, what is the difference between the Amount of imports(as % of merchandise imports) of Ores and metals and Amount of imports(as % of merchandise imports) of Manufactures?
Provide a succinct answer. -60.06. In the year 2004, what is the difference between the Amount of imports(as % of merchandise imports) of Ores and metals and Amount of imports(as % of merchandise imports) of Fuel?
Keep it short and to the point. -11.79. In the year 2004, what is the difference between the Amount of imports(as % of merchandise imports) of Manufactures and Amount of imports(as % of merchandise imports) of Fuel?
Offer a terse response. 48.27. In the year 2005, what is the difference between the Amount of imports(as % of merchandise imports) of Ores and metals and Amount of imports(as % of merchandise imports) of Manufactures?
Provide a short and direct response. -60.71. In the year 2005, what is the difference between the Amount of imports(as % of merchandise imports) in Ores and metals and Amount of imports(as % of merchandise imports) in Fuel?
Provide a succinct answer. -13.16. In the year 2005, what is the difference between the Amount of imports(as % of merchandise imports) in Manufactures and Amount of imports(as % of merchandise imports) in Fuel?
Offer a terse response. 47.55. In the year 2006, what is the difference between the Amount of imports(as % of merchandise imports) in Ores and metals and Amount of imports(as % of merchandise imports) in Manufactures?
Your answer should be very brief. -56.41. In the year 2006, what is the difference between the Amount of imports(as % of merchandise imports) in Ores and metals and Amount of imports(as % of merchandise imports) in Fuel?
Provide a short and direct response. -17.34. In the year 2006, what is the difference between the Amount of imports(as % of merchandise imports) in Manufactures and Amount of imports(as % of merchandise imports) in Fuel?
Keep it short and to the point. 39.07. In the year 2007, what is the difference between the Amount of imports(as % of merchandise imports) of Ores and metals and Amount of imports(as % of merchandise imports) of Manufactures?
Ensure brevity in your answer.  -54.34. In the year 2007, what is the difference between the Amount of imports(as % of merchandise imports) in Ores and metals and Amount of imports(as % of merchandise imports) in Fuel?
Your answer should be compact. -15.12. In the year 2007, what is the difference between the Amount of imports(as % of merchandise imports) in Manufactures and Amount of imports(as % of merchandise imports) in Fuel?
Keep it short and to the point. 39.22. In the year 2008, what is the difference between the Amount of imports(as % of merchandise imports) of Ores and metals and Amount of imports(as % of merchandise imports) of Manufactures?
Make the answer very short. -52.98. In the year 2008, what is the difference between the Amount of imports(as % of merchandise imports) in Ores and metals and Amount of imports(as % of merchandise imports) in Fuel?
Keep it short and to the point. -19.91. In the year 2008, what is the difference between the Amount of imports(as % of merchandise imports) in Manufactures and Amount of imports(as % of merchandise imports) in Fuel?
Your answer should be very brief. 33.07. In the year 2009, what is the difference between the Amount of imports(as % of merchandise imports) in Ores and metals and Amount of imports(as % of merchandise imports) in Manufactures?
Keep it short and to the point. -50.52. In the year 2009, what is the difference between the Amount of imports(as % of merchandise imports) of Ores and metals and Amount of imports(as % of merchandise imports) of Fuel?
Your answer should be compact. -18.39. In the year 2009, what is the difference between the Amount of imports(as % of merchandise imports) of Manufactures and Amount of imports(as % of merchandise imports) of Fuel?
Give a very brief answer. 32.13. In the year 2010, what is the difference between the Amount of imports(as % of merchandise imports) in Ores and metals and Amount of imports(as % of merchandise imports) in Manufactures?
Keep it short and to the point. -48.02. In the year 2010, what is the difference between the Amount of imports(as % of merchandise imports) in Ores and metals and Amount of imports(as % of merchandise imports) in Fuel?
Offer a very short reply. -20.76. In the year 2010, what is the difference between the Amount of imports(as % of merchandise imports) of Manufactures and Amount of imports(as % of merchandise imports) of Fuel?
Give a very brief answer. 27.26. What is the ratio of the Amount of imports(as % of merchandise imports) of Ores and metals in 2002 to that in 2003?
Ensure brevity in your answer.  1.12. What is the ratio of the Amount of imports(as % of merchandise imports) in Manufactures in 2002 to that in 2003?
Ensure brevity in your answer.  0.96. What is the ratio of the Amount of imports(as % of merchandise imports) in Fuel in 2002 to that in 2003?
Provide a short and direct response. 1.11. What is the ratio of the Amount of imports(as % of merchandise imports) of Ores and metals in 2002 to that in 2004?
Your answer should be very brief. 0.98. What is the ratio of the Amount of imports(as % of merchandise imports) of Manufactures in 2002 to that in 2004?
Ensure brevity in your answer.  0.97. What is the ratio of the Amount of imports(as % of merchandise imports) of Fuel in 2002 to that in 2004?
Keep it short and to the point. 0.92. What is the ratio of the Amount of imports(as % of merchandise imports) in Ores and metals in 2002 to that in 2005?
Offer a terse response. 0.97. What is the ratio of the Amount of imports(as % of merchandise imports) of Manufactures in 2002 to that in 2005?
Offer a very short reply. 0.95. What is the ratio of the Amount of imports(as % of merchandise imports) in Fuel in 2002 to that in 2005?
Offer a terse response. 0.84. What is the ratio of the Amount of imports(as % of merchandise imports) of Ores and metals in 2002 to that in 2006?
Make the answer very short. 1. What is the ratio of the Amount of imports(as % of merchandise imports) of Manufactures in 2002 to that in 2006?
Provide a succinct answer. 1.03. What is the ratio of the Amount of imports(as % of merchandise imports) of Fuel in 2002 to that in 2006?
Your response must be concise. 0.66. What is the ratio of the Amount of imports(as % of merchandise imports) in Ores and metals in 2002 to that in 2007?
Keep it short and to the point. 0.66. What is the ratio of the Amount of imports(as % of merchandise imports) in Manufactures in 2002 to that in 2007?
Offer a terse response. 1.04. What is the ratio of the Amount of imports(as % of merchandise imports) in Fuel in 2002 to that in 2007?
Offer a terse response. 0.7. What is the ratio of the Amount of imports(as % of merchandise imports) in Ores and metals in 2002 to that in 2008?
Provide a short and direct response. 0.84. What is the ratio of the Amount of imports(as % of merchandise imports) in Manufactures in 2002 to that in 2008?
Keep it short and to the point. 1.08. What is the ratio of the Amount of imports(as % of merchandise imports) of Fuel in 2002 to that in 2008?
Your answer should be very brief. 0.57. What is the ratio of the Amount of imports(as % of merchandise imports) of Manufactures in 2002 to that in 2009?
Give a very brief answer. 1.14. What is the ratio of the Amount of imports(as % of merchandise imports) in Fuel in 2002 to that in 2009?
Keep it short and to the point. 0.63. What is the ratio of the Amount of imports(as % of merchandise imports) in Ores and metals in 2002 to that in 2010?
Offer a terse response. 1.02. What is the ratio of the Amount of imports(as % of merchandise imports) in Manufactures in 2002 to that in 2010?
Ensure brevity in your answer.  1.2. What is the ratio of the Amount of imports(as % of merchandise imports) of Fuel in 2002 to that in 2010?
Give a very brief answer. 0.57. What is the ratio of the Amount of imports(as % of merchandise imports) in Ores and metals in 2003 to that in 2004?
Ensure brevity in your answer.  0.87. What is the ratio of the Amount of imports(as % of merchandise imports) in Manufactures in 2003 to that in 2004?
Make the answer very short. 1.01. What is the ratio of the Amount of imports(as % of merchandise imports) of Fuel in 2003 to that in 2004?
Offer a very short reply. 0.83. What is the ratio of the Amount of imports(as % of merchandise imports) in Ores and metals in 2003 to that in 2005?
Give a very brief answer. 0.86. What is the ratio of the Amount of imports(as % of merchandise imports) of Fuel in 2003 to that in 2005?
Provide a short and direct response. 0.76. What is the ratio of the Amount of imports(as % of merchandise imports) of Ores and metals in 2003 to that in 2006?
Give a very brief answer. 0.9. What is the ratio of the Amount of imports(as % of merchandise imports) in Manufactures in 2003 to that in 2006?
Provide a short and direct response. 1.07. What is the ratio of the Amount of imports(as % of merchandise imports) in Fuel in 2003 to that in 2006?
Give a very brief answer. 0.6. What is the ratio of the Amount of imports(as % of merchandise imports) in Ores and metals in 2003 to that in 2007?
Keep it short and to the point. 0.59. What is the ratio of the Amount of imports(as % of merchandise imports) of Manufactures in 2003 to that in 2007?
Provide a short and direct response. 1.09. What is the ratio of the Amount of imports(as % of merchandise imports) of Fuel in 2003 to that in 2007?
Your response must be concise. 0.63. What is the ratio of the Amount of imports(as % of merchandise imports) in Ores and metals in 2003 to that in 2008?
Make the answer very short. 0.75. What is the ratio of the Amount of imports(as % of merchandise imports) in Manufactures in 2003 to that in 2008?
Keep it short and to the point. 1.13. What is the ratio of the Amount of imports(as % of merchandise imports) in Fuel in 2003 to that in 2008?
Provide a succinct answer. 0.52. What is the ratio of the Amount of imports(as % of merchandise imports) of Ores and metals in 2003 to that in 2009?
Offer a very short reply. 0.89. What is the ratio of the Amount of imports(as % of merchandise imports) of Manufactures in 2003 to that in 2009?
Your response must be concise. 1.19. What is the ratio of the Amount of imports(as % of merchandise imports) in Fuel in 2003 to that in 2009?
Offer a very short reply. 0.57. What is the ratio of the Amount of imports(as % of merchandise imports) of Ores and metals in 2003 to that in 2010?
Your answer should be very brief. 0.91. What is the ratio of the Amount of imports(as % of merchandise imports) of Manufactures in 2003 to that in 2010?
Give a very brief answer. 1.25. What is the ratio of the Amount of imports(as % of merchandise imports) of Fuel in 2003 to that in 2010?
Your response must be concise. 0.51. What is the ratio of the Amount of imports(as % of merchandise imports) in Manufactures in 2004 to that in 2005?
Provide a short and direct response. 0.99. What is the ratio of the Amount of imports(as % of merchandise imports) in Fuel in 2004 to that in 2005?
Ensure brevity in your answer.  0.91. What is the ratio of the Amount of imports(as % of merchandise imports) in Ores and metals in 2004 to that in 2006?
Ensure brevity in your answer.  1.03. What is the ratio of the Amount of imports(as % of merchandise imports) of Manufactures in 2004 to that in 2006?
Keep it short and to the point. 1.06. What is the ratio of the Amount of imports(as % of merchandise imports) of Fuel in 2004 to that in 2006?
Keep it short and to the point. 0.72. What is the ratio of the Amount of imports(as % of merchandise imports) in Ores and metals in 2004 to that in 2007?
Ensure brevity in your answer.  0.68. What is the ratio of the Amount of imports(as % of merchandise imports) of Manufactures in 2004 to that in 2007?
Give a very brief answer. 1.08. What is the ratio of the Amount of imports(as % of merchandise imports) in Fuel in 2004 to that in 2007?
Your response must be concise. 0.76. What is the ratio of the Amount of imports(as % of merchandise imports) in Ores and metals in 2004 to that in 2008?
Offer a very short reply. 0.86. What is the ratio of the Amount of imports(as % of merchandise imports) in Manufactures in 2004 to that in 2008?
Give a very brief answer. 1.12. What is the ratio of the Amount of imports(as % of merchandise imports) in Fuel in 2004 to that in 2008?
Provide a succinct answer. 0.62. What is the ratio of the Amount of imports(as % of merchandise imports) of Ores and metals in 2004 to that in 2009?
Provide a short and direct response. 1.03. What is the ratio of the Amount of imports(as % of merchandise imports) of Manufactures in 2004 to that in 2009?
Provide a succinct answer. 1.18. What is the ratio of the Amount of imports(as % of merchandise imports) in Fuel in 2004 to that in 2009?
Your answer should be very brief. 0.68. What is the ratio of the Amount of imports(as % of merchandise imports) of Ores and metals in 2004 to that in 2010?
Your response must be concise. 1.05. What is the ratio of the Amount of imports(as % of merchandise imports) in Manufactures in 2004 to that in 2010?
Make the answer very short. 1.24. What is the ratio of the Amount of imports(as % of merchandise imports) of Fuel in 2004 to that in 2010?
Provide a short and direct response. 0.61. What is the ratio of the Amount of imports(as % of merchandise imports) in Ores and metals in 2005 to that in 2006?
Provide a succinct answer. 1.04. What is the ratio of the Amount of imports(as % of merchandise imports) in Manufactures in 2005 to that in 2006?
Your response must be concise. 1.07. What is the ratio of the Amount of imports(as % of merchandise imports) of Fuel in 2005 to that in 2006?
Your answer should be compact. 0.79. What is the ratio of the Amount of imports(as % of merchandise imports) of Ores and metals in 2005 to that in 2007?
Offer a very short reply. 0.69. What is the ratio of the Amount of imports(as % of merchandise imports) of Manufactures in 2005 to that in 2007?
Your answer should be compact. 1.09. What is the ratio of the Amount of imports(as % of merchandise imports) in Fuel in 2005 to that in 2007?
Your answer should be compact. 0.84. What is the ratio of the Amount of imports(as % of merchandise imports) of Ores and metals in 2005 to that in 2008?
Offer a very short reply. 0.87. What is the ratio of the Amount of imports(as % of merchandise imports) of Manufactures in 2005 to that in 2008?
Your answer should be very brief. 1.13. What is the ratio of the Amount of imports(as % of merchandise imports) in Fuel in 2005 to that in 2008?
Your answer should be very brief. 0.69. What is the ratio of the Amount of imports(as % of merchandise imports) of Ores and metals in 2005 to that in 2009?
Ensure brevity in your answer.  1.03. What is the ratio of the Amount of imports(as % of merchandise imports) of Manufactures in 2005 to that in 2009?
Offer a terse response. 1.19. What is the ratio of the Amount of imports(as % of merchandise imports) in Fuel in 2005 to that in 2009?
Your answer should be very brief. 0.75. What is the ratio of the Amount of imports(as % of merchandise imports) of Ores and metals in 2005 to that in 2010?
Your response must be concise. 1.06. What is the ratio of the Amount of imports(as % of merchandise imports) of Manufactures in 2005 to that in 2010?
Offer a terse response. 1.25. What is the ratio of the Amount of imports(as % of merchandise imports) in Fuel in 2005 to that in 2010?
Your answer should be compact. 0.67. What is the ratio of the Amount of imports(as % of merchandise imports) of Ores and metals in 2006 to that in 2007?
Offer a very short reply. 0.66. What is the ratio of the Amount of imports(as % of merchandise imports) of Manufactures in 2006 to that in 2007?
Your answer should be very brief. 1.02. What is the ratio of the Amount of imports(as % of merchandise imports) in Fuel in 2006 to that in 2007?
Keep it short and to the point. 1.06. What is the ratio of the Amount of imports(as % of merchandise imports) of Ores and metals in 2006 to that in 2008?
Offer a very short reply. 0.84. What is the ratio of the Amount of imports(as % of merchandise imports) in Manufactures in 2006 to that in 2008?
Make the answer very short. 1.05. What is the ratio of the Amount of imports(as % of merchandise imports) of Fuel in 2006 to that in 2008?
Your answer should be compact. 0.87. What is the ratio of the Amount of imports(as % of merchandise imports) in Ores and metals in 2006 to that in 2009?
Offer a terse response. 1. What is the ratio of the Amount of imports(as % of merchandise imports) in Manufactures in 2006 to that in 2009?
Offer a terse response. 1.11. What is the ratio of the Amount of imports(as % of merchandise imports) of Fuel in 2006 to that in 2009?
Provide a succinct answer. 0.95. What is the ratio of the Amount of imports(as % of merchandise imports) of Ores and metals in 2006 to that in 2010?
Offer a very short reply. 1.02. What is the ratio of the Amount of imports(as % of merchandise imports) of Manufactures in 2006 to that in 2010?
Your answer should be compact. 1.17. What is the ratio of the Amount of imports(as % of merchandise imports) of Fuel in 2006 to that in 2010?
Provide a short and direct response. 0.85. What is the ratio of the Amount of imports(as % of merchandise imports) in Ores and metals in 2007 to that in 2008?
Your response must be concise. 1.27. What is the ratio of the Amount of imports(as % of merchandise imports) in Manufactures in 2007 to that in 2008?
Provide a short and direct response. 1.04. What is the ratio of the Amount of imports(as % of merchandise imports) of Fuel in 2007 to that in 2008?
Give a very brief answer. 0.82. What is the ratio of the Amount of imports(as % of merchandise imports) of Ores and metals in 2007 to that in 2009?
Give a very brief answer. 1.51. What is the ratio of the Amount of imports(as % of merchandise imports) of Manufactures in 2007 to that in 2009?
Your answer should be very brief. 1.09. What is the ratio of the Amount of imports(as % of merchandise imports) in Fuel in 2007 to that in 2009?
Give a very brief answer. 0.9. What is the ratio of the Amount of imports(as % of merchandise imports) of Ores and metals in 2007 to that in 2010?
Ensure brevity in your answer.  1.54. What is the ratio of the Amount of imports(as % of merchandise imports) of Manufactures in 2007 to that in 2010?
Your answer should be very brief. 1.15. What is the ratio of the Amount of imports(as % of merchandise imports) in Fuel in 2007 to that in 2010?
Keep it short and to the point. 0.81. What is the ratio of the Amount of imports(as % of merchandise imports) of Ores and metals in 2008 to that in 2009?
Offer a very short reply. 1.19. What is the ratio of the Amount of imports(as % of merchandise imports) of Manufactures in 2008 to that in 2009?
Offer a terse response. 1.05. What is the ratio of the Amount of imports(as % of merchandise imports) of Fuel in 2008 to that in 2009?
Make the answer very short. 1.09. What is the ratio of the Amount of imports(as % of merchandise imports) of Ores and metals in 2008 to that in 2010?
Offer a terse response. 1.22. What is the ratio of the Amount of imports(as % of merchandise imports) in Manufactures in 2008 to that in 2010?
Keep it short and to the point. 1.11. What is the ratio of the Amount of imports(as % of merchandise imports) of Fuel in 2008 to that in 2010?
Offer a very short reply. 0.98. What is the ratio of the Amount of imports(as % of merchandise imports) in Ores and metals in 2009 to that in 2010?
Your answer should be very brief. 1.02. What is the ratio of the Amount of imports(as % of merchandise imports) in Manufactures in 2009 to that in 2010?
Keep it short and to the point. 1.05. What is the ratio of the Amount of imports(as % of merchandise imports) of Fuel in 2009 to that in 2010?
Offer a terse response. 0.9. What is the difference between the highest and the second highest Amount of imports(as % of merchandise imports) in Ores and metals?
Make the answer very short. 0.72. What is the difference between the highest and the second highest Amount of imports(as % of merchandise imports) of Manufactures?
Your response must be concise. 0.01. What is the difference between the highest and the second highest Amount of imports(as % of merchandise imports) of Fuel?
Provide a short and direct response. 0.38. What is the difference between the highest and the lowest Amount of imports(as % of merchandise imports) in Ores and metals?
Provide a succinct answer. 1.39. What is the difference between the highest and the lowest Amount of imports(as % of merchandise imports) in Manufactures?
Keep it short and to the point. 12.81. What is the difference between the highest and the lowest Amount of imports(as % of merchandise imports) of Fuel?
Provide a short and direct response. 11.25. 